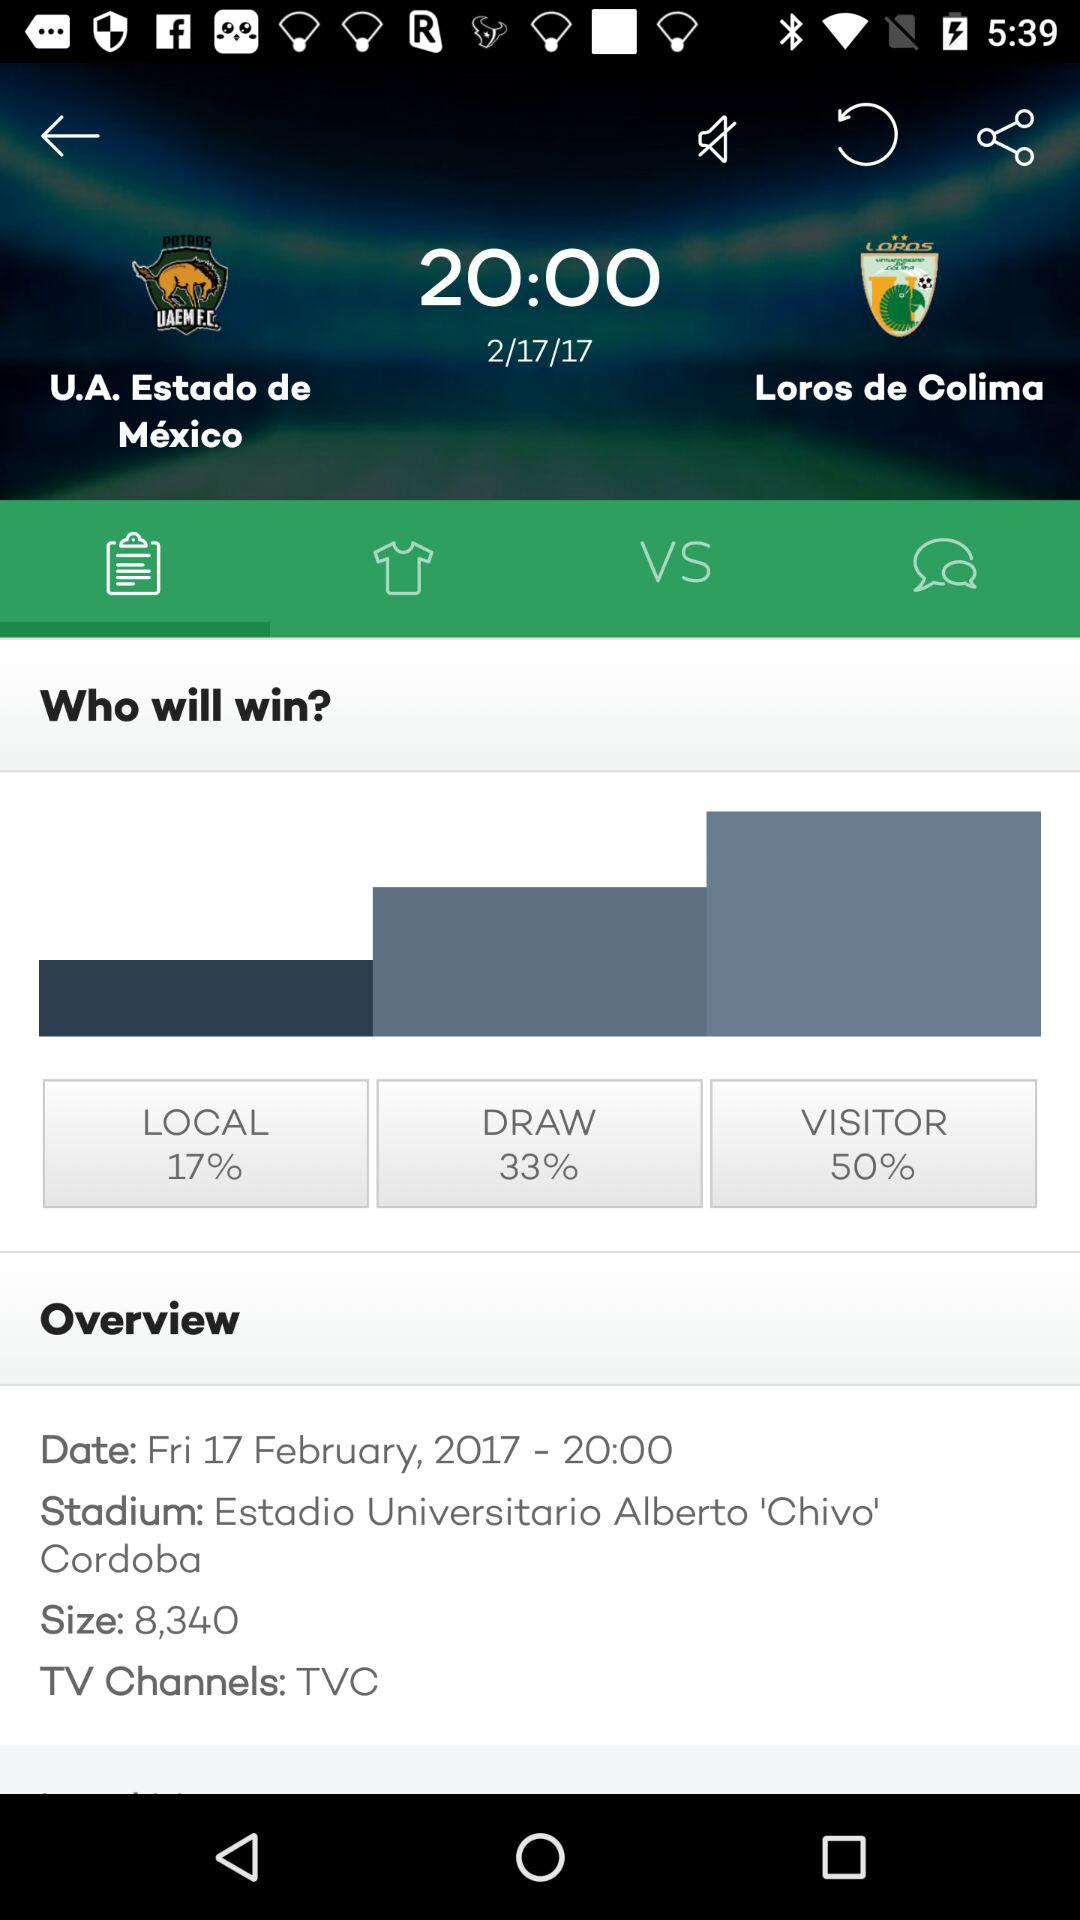What is the percentage of draw? The percentage of draw is 33. 